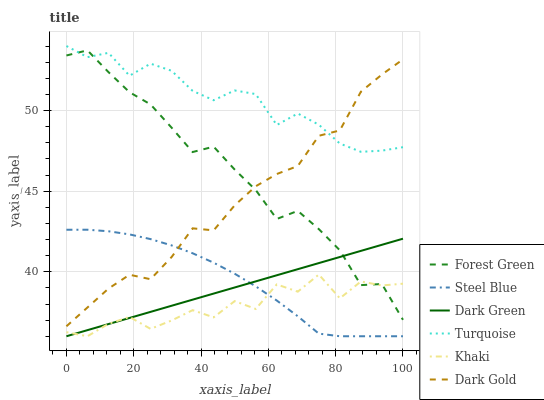Does Khaki have the minimum area under the curve?
Answer yes or no. Yes. Does Turquoise have the maximum area under the curve?
Answer yes or no. Yes. Does Dark Gold have the minimum area under the curve?
Answer yes or no. No. Does Dark Gold have the maximum area under the curve?
Answer yes or no. No. Is Dark Green the smoothest?
Answer yes or no. Yes. Is Khaki the roughest?
Answer yes or no. Yes. Is Dark Gold the smoothest?
Answer yes or no. No. Is Dark Gold the roughest?
Answer yes or no. No. Does Dark Gold have the lowest value?
Answer yes or no. No. Does Turquoise have the highest value?
Answer yes or no. Yes. Does Dark Gold have the highest value?
Answer yes or no. No. Is Dark Green less than Dark Gold?
Answer yes or no. Yes. Is Dark Gold greater than Dark Green?
Answer yes or no. Yes. Does Khaki intersect Dark Green?
Answer yes or no. Yes. Is Khaki less than Dark Green?
Answer yes or no. No. Is Khaki greater than Dark Green?
Answer yes or no. No. Does Dark Green intersect Dark Gold?
Answer yes or no. No. 